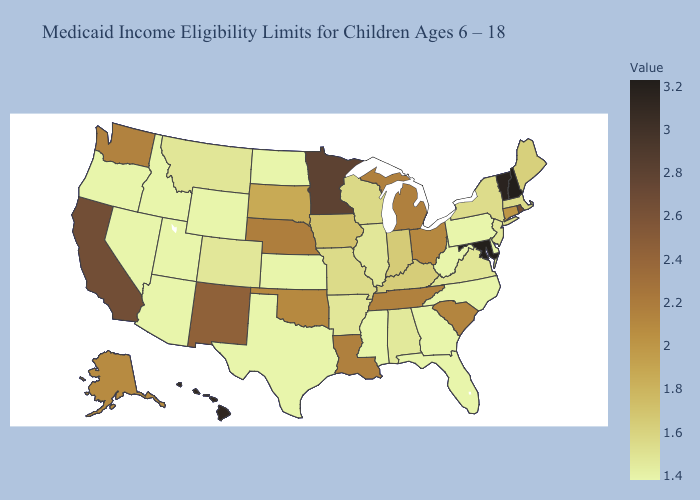Does Hawaii have the lowest value in the USA?
Answer briefly. No. Among the states that border Connecticut , which have the highest value?
Quick response, please. Rhode Island. Is the legend a continuous bar?
Short answer required. Yes. Among the states that border Alabama , which have the highest value?
Concise answer only. Tennessee. 